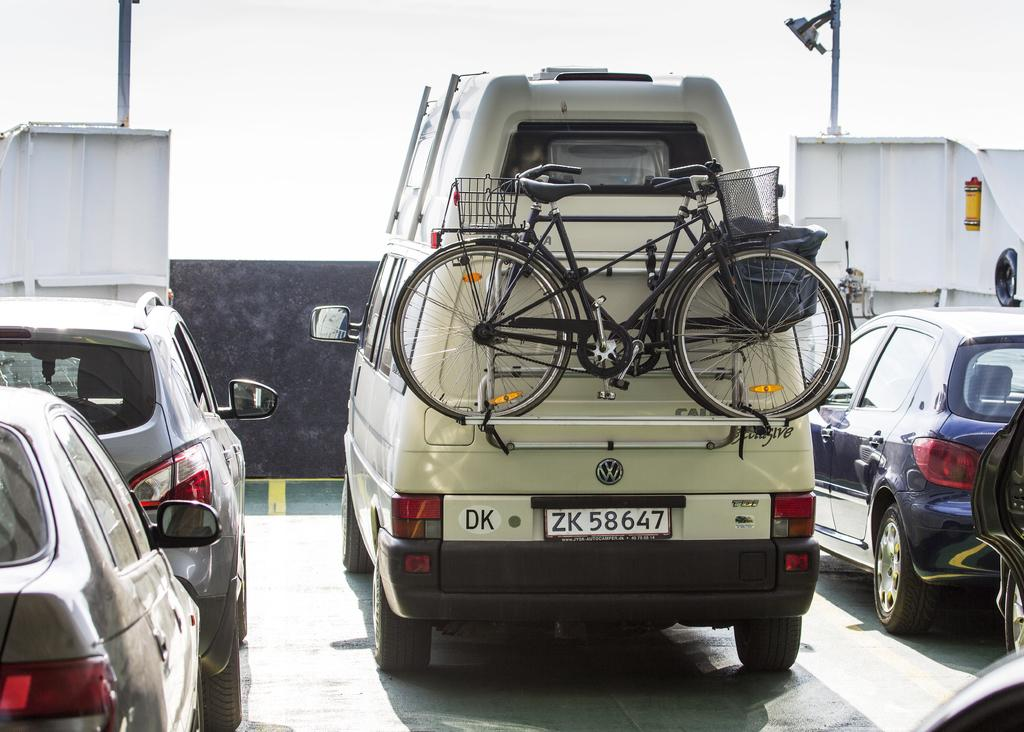What types of vehicles are in the middle of the image? There are vehicles in the middle of the image, including cars and bicycles. What can be observed about the vehicles in the image? The vehicles are of different colors. Where are the flowers growing in the image? There are no flowers present in the image; it features vehicles of different colors. What is in the pocket of the person riding the bicycle in the image? There is no person or pocket visible in the image; it only shows vehicles. 